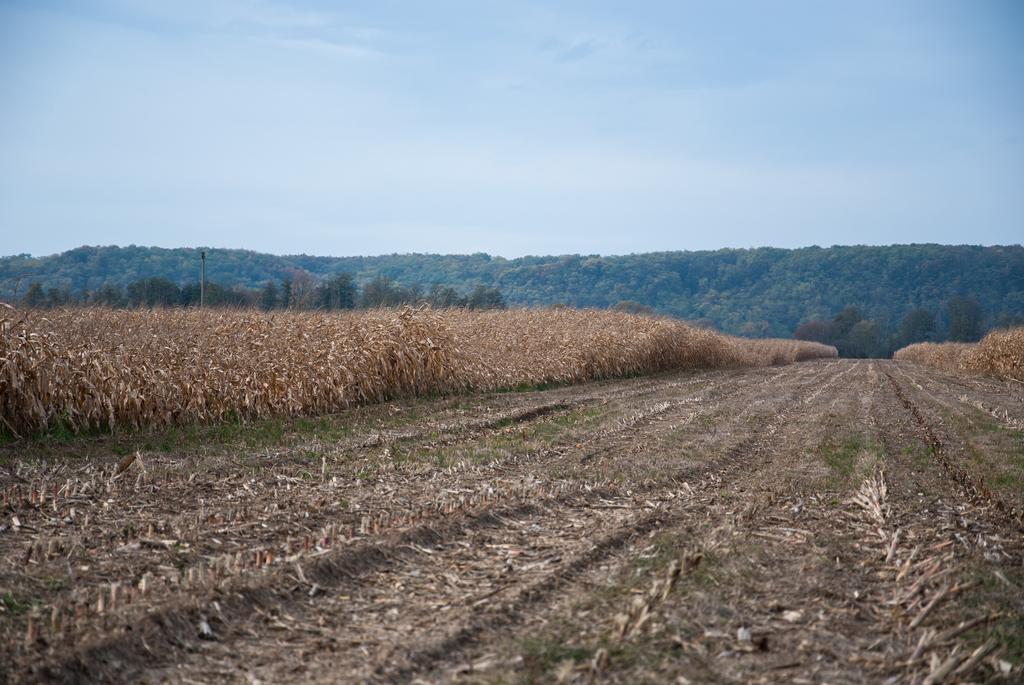Can you describe this image briefly? These are dried plants. Background there are trees. Sky is in blue color. 